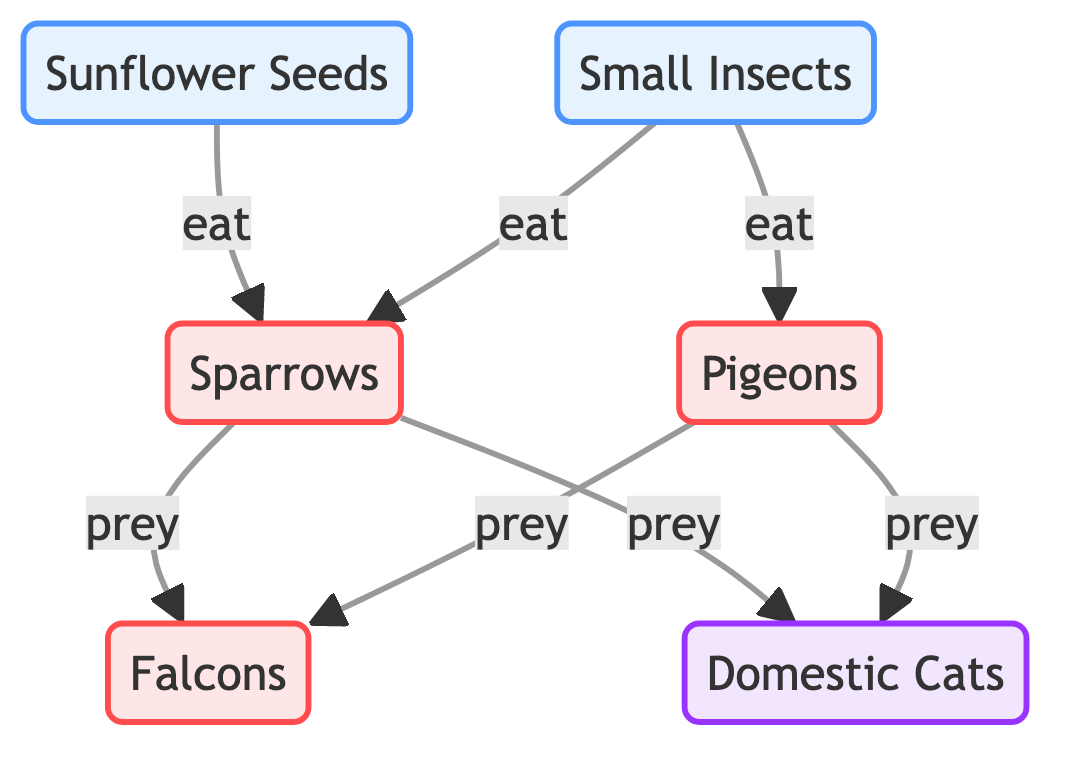What are the two food sources for sparrows? The diagram indicates that sparrows eat sunflower seeds and small insects. By examining the flow from the two food source nodes, we can conclusively identify them.
Answer: sunflower seeds, small insects How many types of birds are represented in the diagram? Counting the bird nodes presents pigeons, sparrows, and falcons as the three types. Thus, the total number of bird types is three.
Answer: 3 Which predator preys on both pigeons and sparrows? The diagram shows that falcons and domestic cats both prey on these two types of birds. However, the question was seeking a singular predator, leading us to falcons as a specific answer here, while we acknowledge the presence of both predators.
Answer: falcons What type of food do pigeons consume? From the diagram, we see that pigeons have a direct link to small insects as their source of food; hence, they consume that type of food.
Answer: small insects Which birds are preyed upon by domestic cats? Looking at the diagram, domestic cats prey upon sparrows and pigeons. The flow indicates these relationships directly, detailing that both birds are targeted by cats.
Answer: sparrows, pigeons How many edges are in the diagram? To find the number of edges, one counts the lines connecting the nodes. The edges are sunflower seeds to sparrows (1), small insects to sparrows (2), small insects to pigeons (3), sparrows to falcons (4), pigeons to falcons (5), sparrows to domestic cats (6), and pigeons to domestic cats (7), totaling seven edges.
Answer: 7 What is the relationship between small insects and pigeons? The diagram explicitly shows that small insects serve as a food source for pigeons, establishing a direct relationship where small insects are eaten by pigeons.
Answer: eat Which bird is at the top of the food chain in this diagram? By analyzing the eating and predation relationships shown in the diagram, falcons emerge as the top predator, preying on both sparrows and pigeons, indicating their position in the food chain hierarchy.
Answer: falcons What color represents predators in the diagram? The legend in the diagram indicates that the color associated with predators is a light purple or lavender tint, clearly defining them as a visual class.
Answer: light purple 